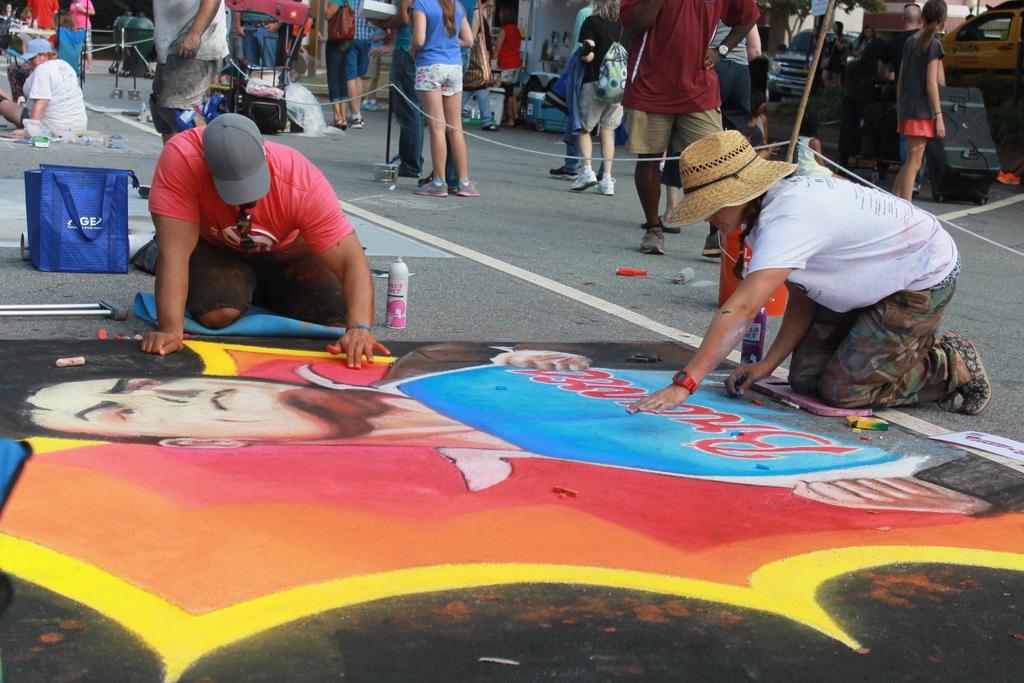Describe this image in one or two sentences. In this image I can see two persons painting on the road. In the background I can see few persons walking. 